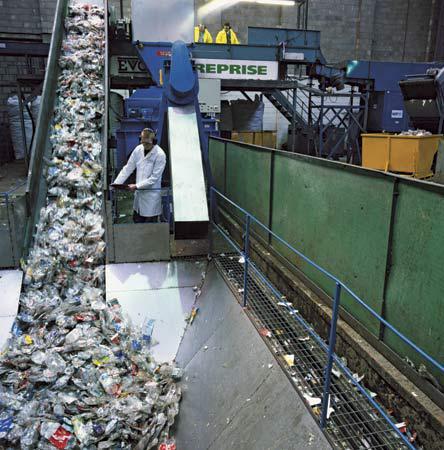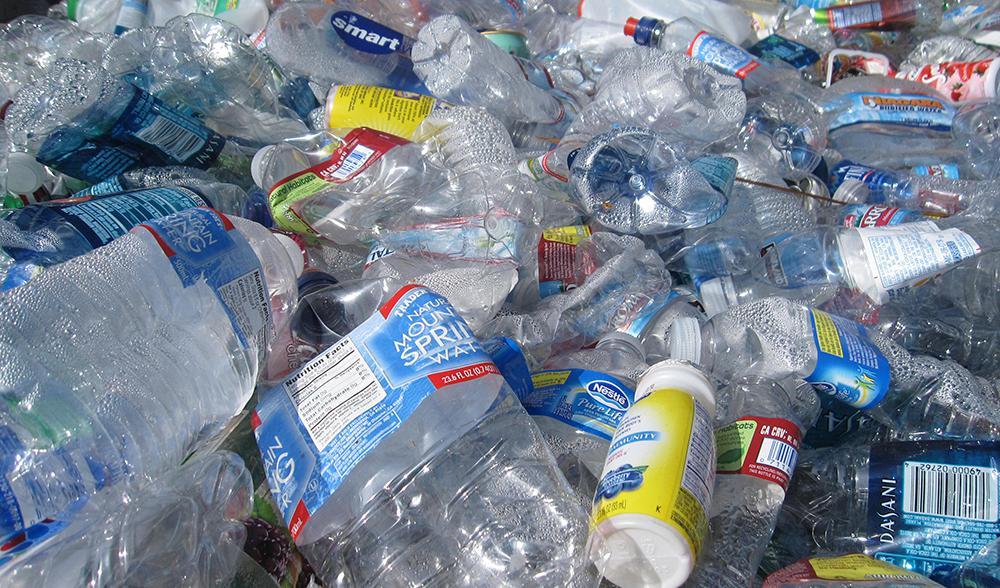The first image is the image on the left, the second image is the image on the right. For the images shown, is this caption "A person in an orange shirt stands near a belt of bottles." true? Answer yes or no. No. 